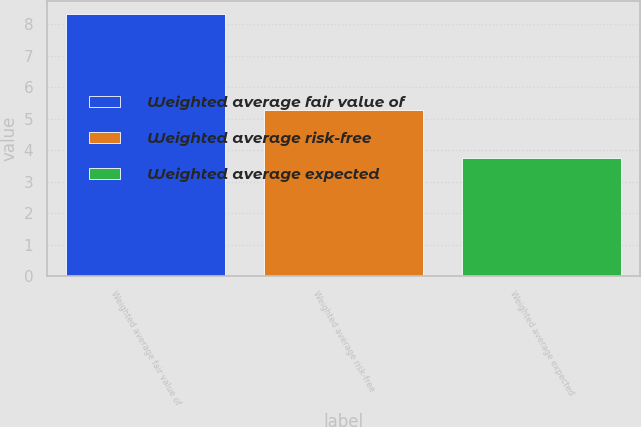<chart> <loc_0><loc_0><loc_500><loc_500><bar_chart><fcel>Weighted average fair value of<fcel>Weighted average risk-free<fcel>Weighted average expected<nl><fcel>8.33<fcel>5.29<fcel>3.77<nl></chart> 